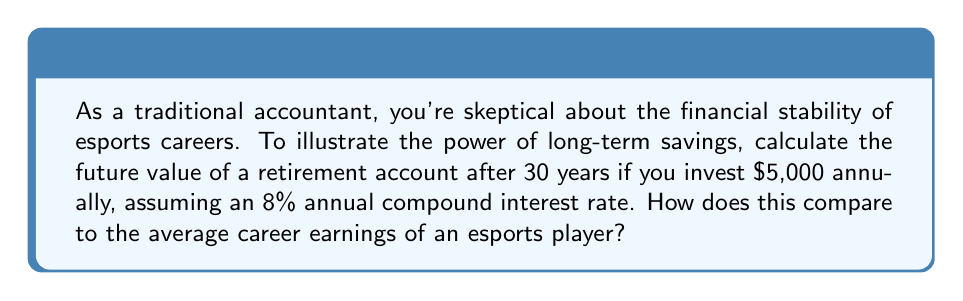Could you help me with this problem? To solve this problem, we'll use the compound interest formula for periodic contributions:

$$FV = PMT \cdot \frac{(1 + r)^n - 1}{r}$$

Where:
$FV$ = Future Value
$PMT$ = Annual Payment (contribution)
$r$ = Annual Interest Rate
$n$ = Number of Years

Given:
$PMT = \$5,000$
$r = 8\% = 0.08$
$n = 30$ years

Let's substitute these values into the formula:

$$FV = 5000 \cdot \frac{(1 + 0.08)^{30} - 1}{0.08}$$

$$FV = 5000 \cdot \frac{10.0627 - 1}{0.08}$$

$$FV = 5000 \cdot 113.2833$$

$$FV = 566,416.50$$

The future value of the retirement account after 30 years would be approximately $566,416.50.

To compare this with esports earnings:
According to various sources, the average career earnings of an esports player range from $50,000 to $300,000, with top players earning millions. However, most careers in esports are short-lived, often less than 5 years.

The calculated retirement savings significantly exceed the average career earnings of most esports players, demonstrating the power of consistent, long-term investing and compound interest.
Answer: $566,416.50 